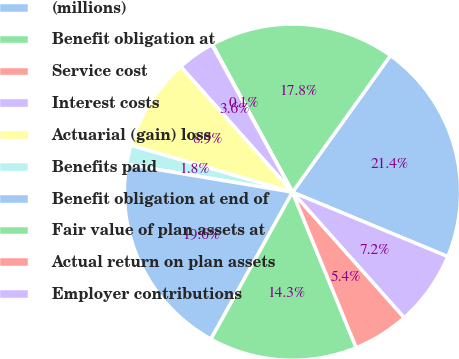<chart> <loc_0><loc_0><loc_500><loc_500><pie_chart><fcel>(millions)<fcel>Benefit obligation at<fcel>Service cost<fcel>Interest costs<fcel>Actuarial (gain) loss<fcel>Benefits paid<fcel>Benefit obligation at end of<fcel>Fair value of plan assets at<fcel>Actual return on plan assets<fcel>Employer contributions<nl><fcel>21.36%<fcel>17.81%<fcel>0.06%<fcel>3.61%<fcel>8.94%<fcel>1.84%<fcel>19.58%<fcel>14.26%<fcel>5.39%<fcel>7.16%<nl></chart> 